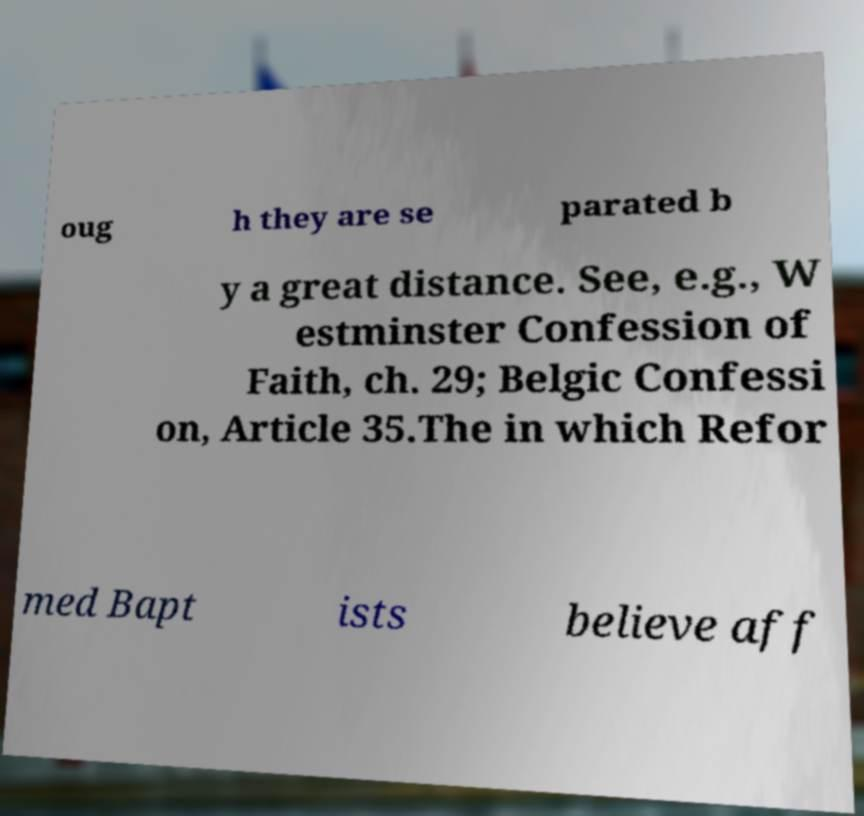Can you read and provide the text displayed in the image?This photo seems to have some interesting text. Can you extract and type it out for me? oug h they are se parated b y a great distance. See, e.g., W estminster Confession of Faith, ch. 29; Belgic Confessi on, Article 35.The in which Refor med Bapt ists believe aff 